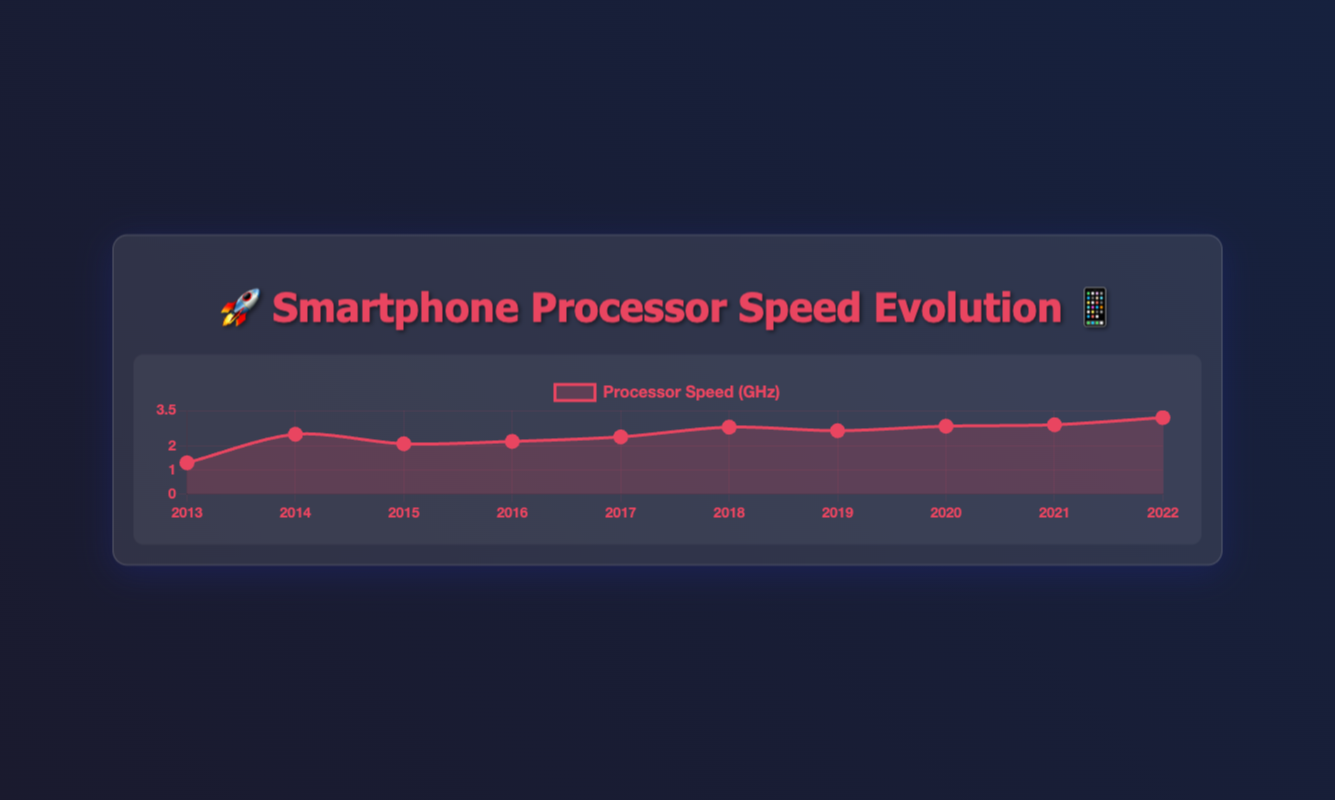What is the maximum processor speed in the data? The maximum value in the dataset is the peak of the line graph. By looking at the height of the lines, we see that the maximum processor speed is 3.2 GHz, corresponding to the Apple A15 Bionic in 2022.
Answer: 3.2 GHz Which years show an increase in processor speed compared to the previous year? To determine this, we compare each year's processor speed with the previous year's speed. The years showing an increase are from 2013 to 2014, 2017 to 2018, 2018 to 2019, 2019 to 2020, 2020 to 2021, and 2021 to 2022.
Answer: 2014, 2018, 2019, 2020, 2021, 2022 Which processor had the lowest speed, and in what year? The lowest point on the graph represents the minimum value in the dataset. The lowest processor speed is 1.3 GHz, which corresponds to the Apple A7 in 2013.
Answer: Apple A7, 2013 How much did the processor speed increase from 2013 to 2022? To find the increase, subtract the 2013 speed from the 2022 speed. The speeds are 1.3 GHz in 2013 and 3.2 GHz in 2022. The increase is 3.2 - 1.3 = 1.9 GHz.
Answer: 1.9 GHz What is the average processor speed over the decade? To find the average, sum all the processor speeds and divide by the number of years. Sum: 1.3 + 2.5 + 2.1 + 2.2 + 2.39 + 2.8 + 2.65 + 2.84 + 2.9 + 3.2. The total is 25.88 GHz. Divide by 10 years: 25.88 / 10 = 2.588 GHz.
Answer: 2.588 GHz Which processor showed the highest speed increase compared to the previous year? Check the difference between consecutive years and find the maximum. The largest increase is between 2021 (2.9 GHz) and 2022 (3.2 GHz), which is 3.2 - 2.9 = 0.3 GHz.
Answer: Apple A15 Bionic, 2022 How did the processor speed trend from 2015 to 2018? Analyze the trend by looking at the data points. From 2015 (2.1 GHz) to 2016 (2.2 GHz), there is a small increase. From 2016 to 2017 (2.39 GHz), another small increase is seen. A more significant jump occurs in 2018 (2.8 GHz). Overall, the trend from 2015 to 2018 is increasing.
Answer: Increasing Which year had the closest processor speed to the average speed over the decade? The average speed calculated is 2.588 GHz. By comparing yearly speeds to this average, 2019's speed (2.65 GHz) is the closest.
Answer: 2019 How does the speed of the Qualcomm Snapdragon 865 in 2020 compare with the Apple A11 Bionic in 2017? Compare the values from 2020 and 2017 directly. The Qualcomm Snapdragon 865 in 2020 has 2.84 GHz, while the Apple A11 Bionic in 2017 has 2.39 GHz. The Snapdragon 865 has a higher speed.
Answer: Snapdragon 865 is faster 